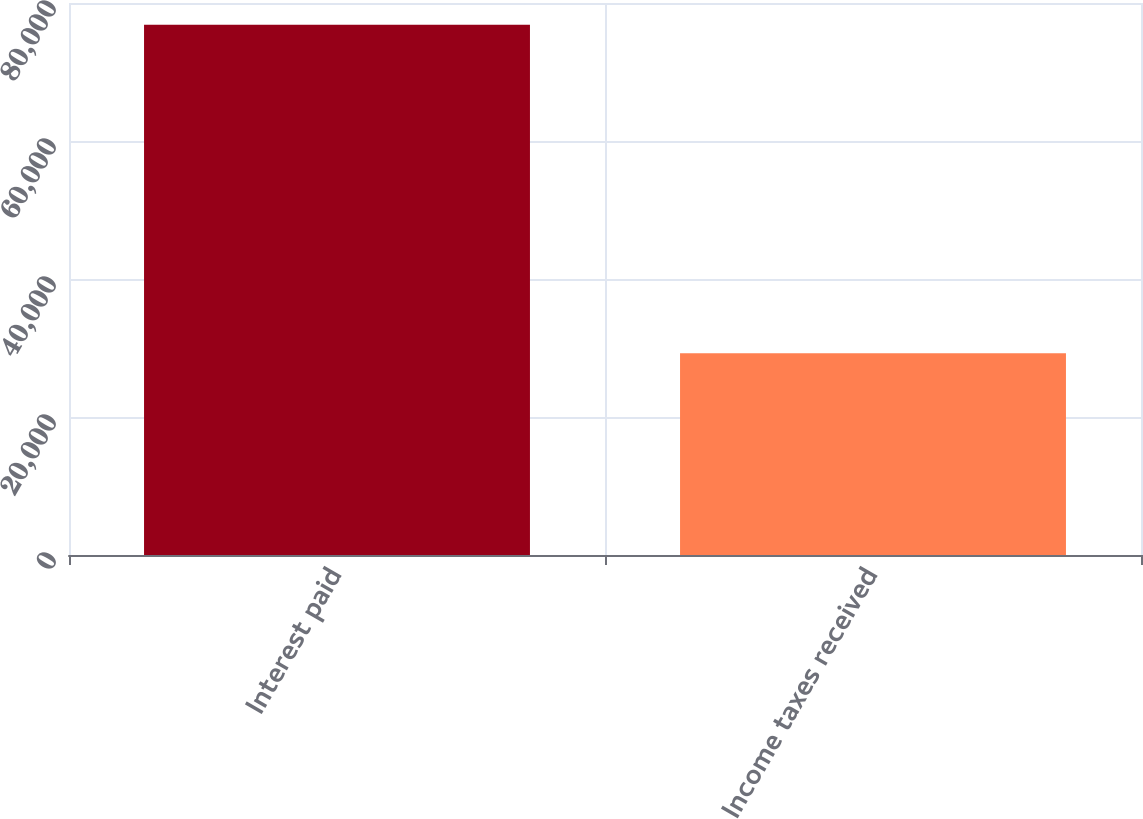Convert chart to OTSL. <chart><loc_0><loc_0><loc_500><loc_500><bar_chart><fcel>Interest paid<fcel>Income taxes received<nl><fcel>76833<fcel>29251<nl></chart> 